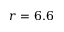<formula> <loc_0><loc_0><loc_500><loc_500>r = 6 . 6</formula> 